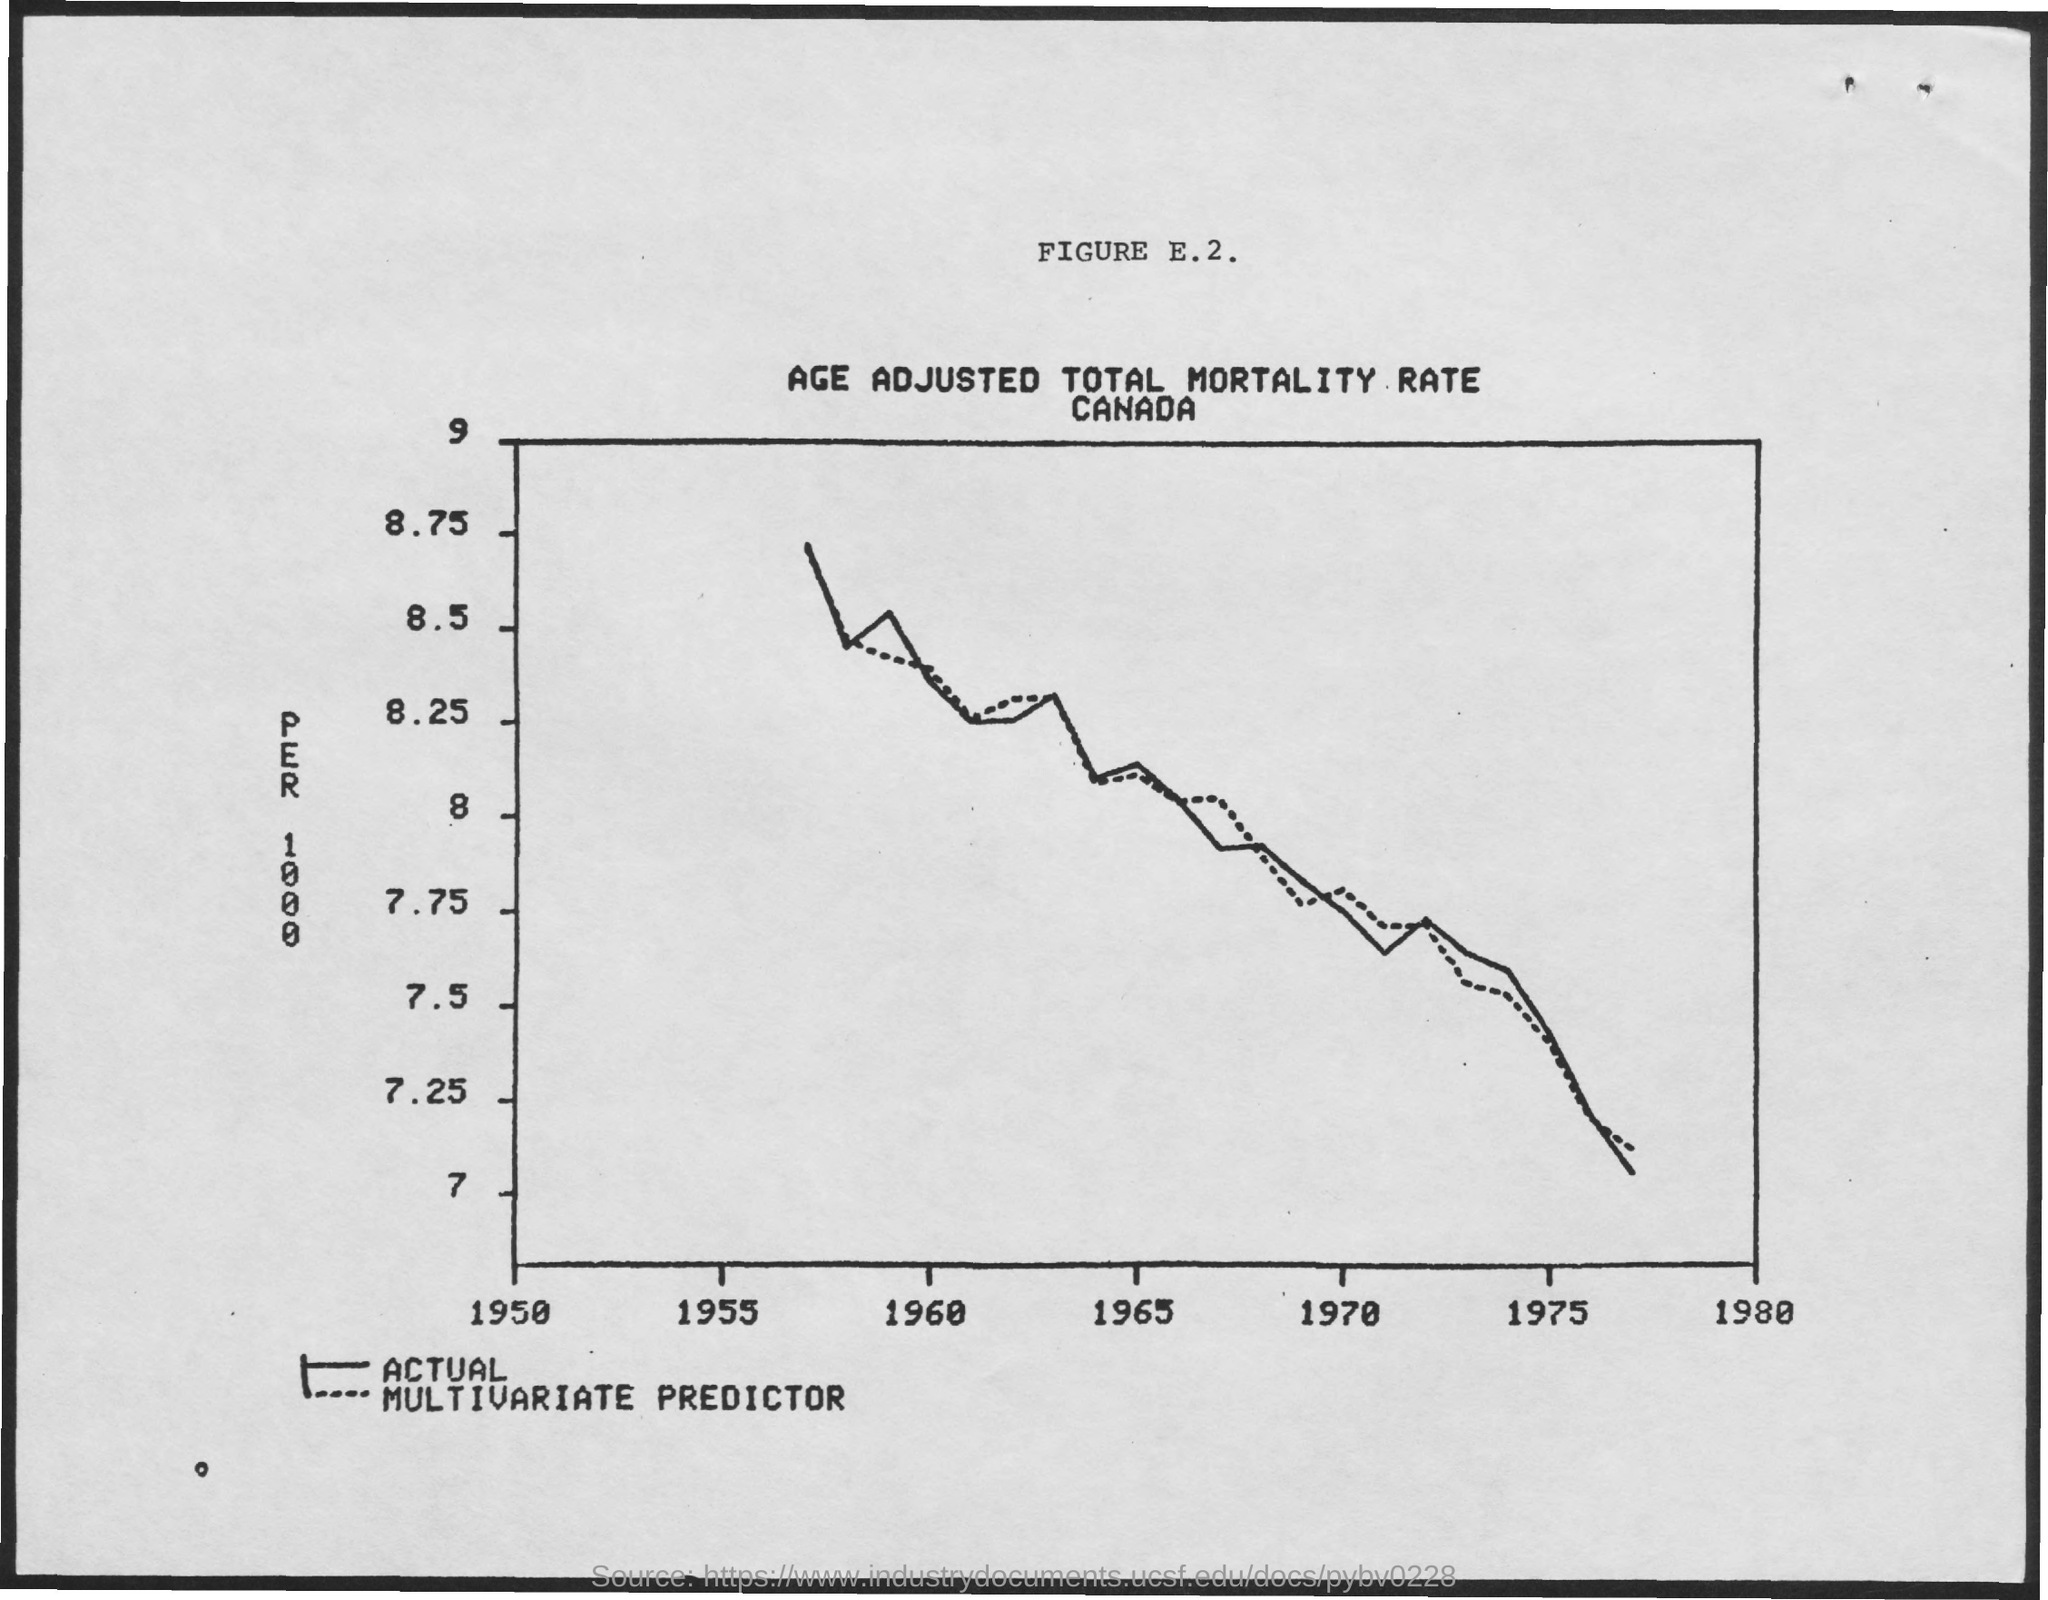What is the title of FIGURE E.2.?
Provide a succinct answer. AGE ADJUSTED TOTAL MORTALITY RATE. 